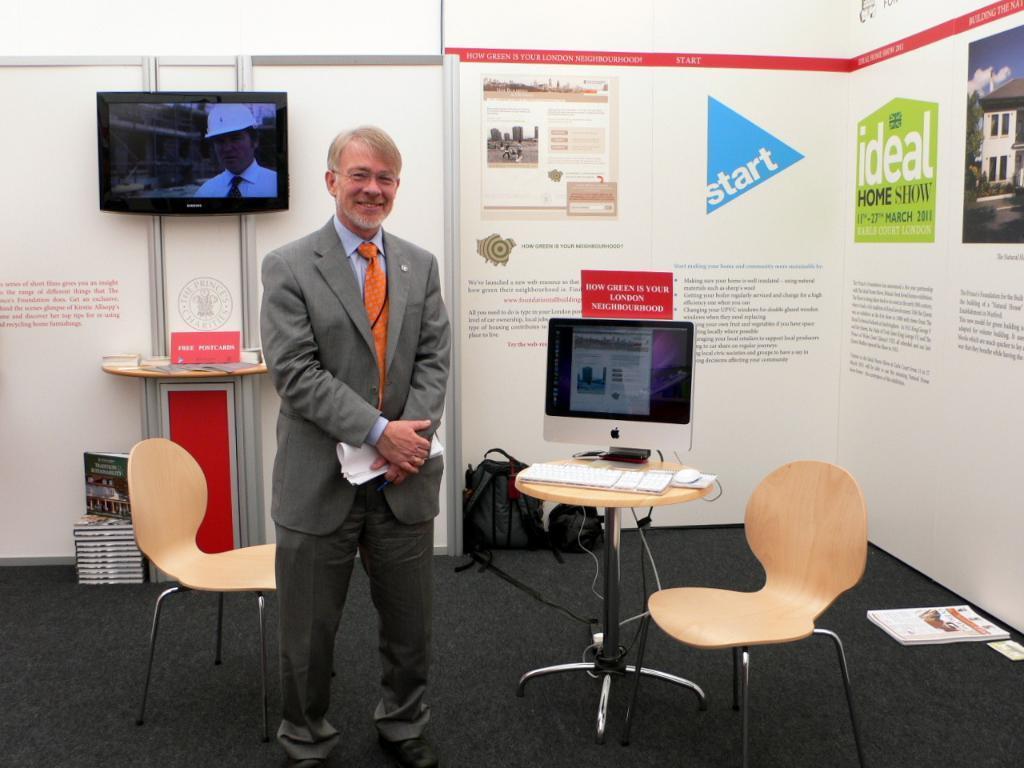Please provide a concise description of this image. This person standing and smiling and holding papers. We can see chairs,table,bags,books on the floor,on the table there are monitor,keyboard,mouse. On the background we can see wall,posters,television,objects on the table. 